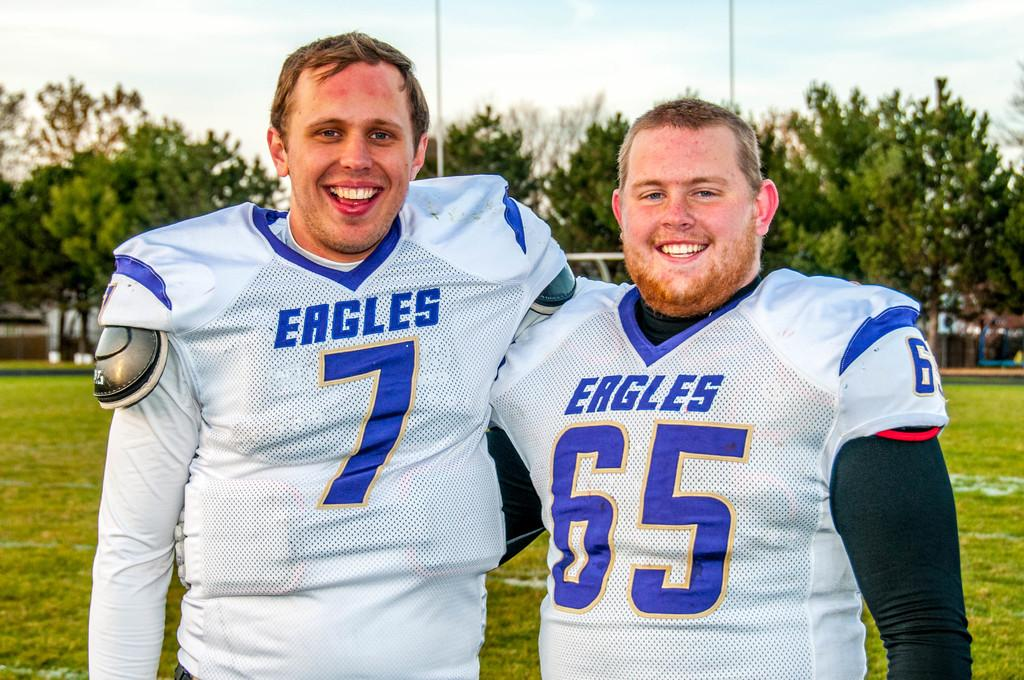<image>
Share a concise interpretation of the image provided. Two football players for the Eagles, in uniform, wearing number 7 and 65, have their arms around each other on a field. 